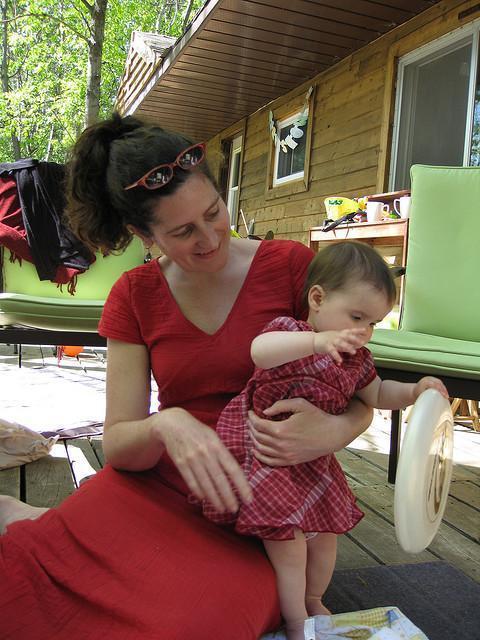How many people are visible?
Give a very brief answer. 2. 